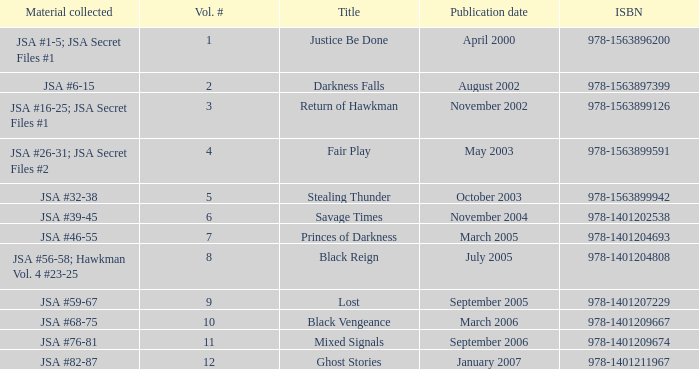What's the Material collected for the 978-1401209674 ISBN? JSA #76-81. Would you be able to parse every entry in this table? {'header': ['Material collected', 'Vol. #', 'Title', 'Publication date', 'ISBN'], 'rows': [['JSA #1-5; JSA Secret Files #1', '1', 'Justice Be Done', 'April 2000', '978-1563896200'], ['JSA #6-15', '2', 'Darkness Falls', 'August 2002', '978-1563897399'], ['JSA #16-25; JSA Secret Files #1', '3', 'Return of Hawkman', 'November 2002', '978-1563899126'], ['JSA #26-31; JSA Secret Files #2', '4', 'Fair Play', 'May 2003', '978-1563899591'], ['JSA #32-38', '5', 'Stealing Thunder', 'October 2003', '978-1563899942'], ['JSA #39-45', '6', 'Savage Times', 'November 2004', '978-1401202538'], ['JSA #46-55', '7', 'Princes of Darkness', 'March 2005', '978-1401204693'], ['JSA #56-58; Hawkman Vol. 4 #23-25', '8', 'Black Reign', 'July 2005', '978-1401204808'], ['JSA #59-67', '9', 'Lost', 'September 2005', '978-1401207229'], ['JSA #68-75', '10', 'Black Vengeance', 'March 2006', '978-1401209667'], ['JSA #76-81', '11', 'Mixed Signals', 'September 2006', '978-1401209674'], ['JSA #82-87', '12', 'Ghost Stories', 'January 2007', '978-1401211967']]} 